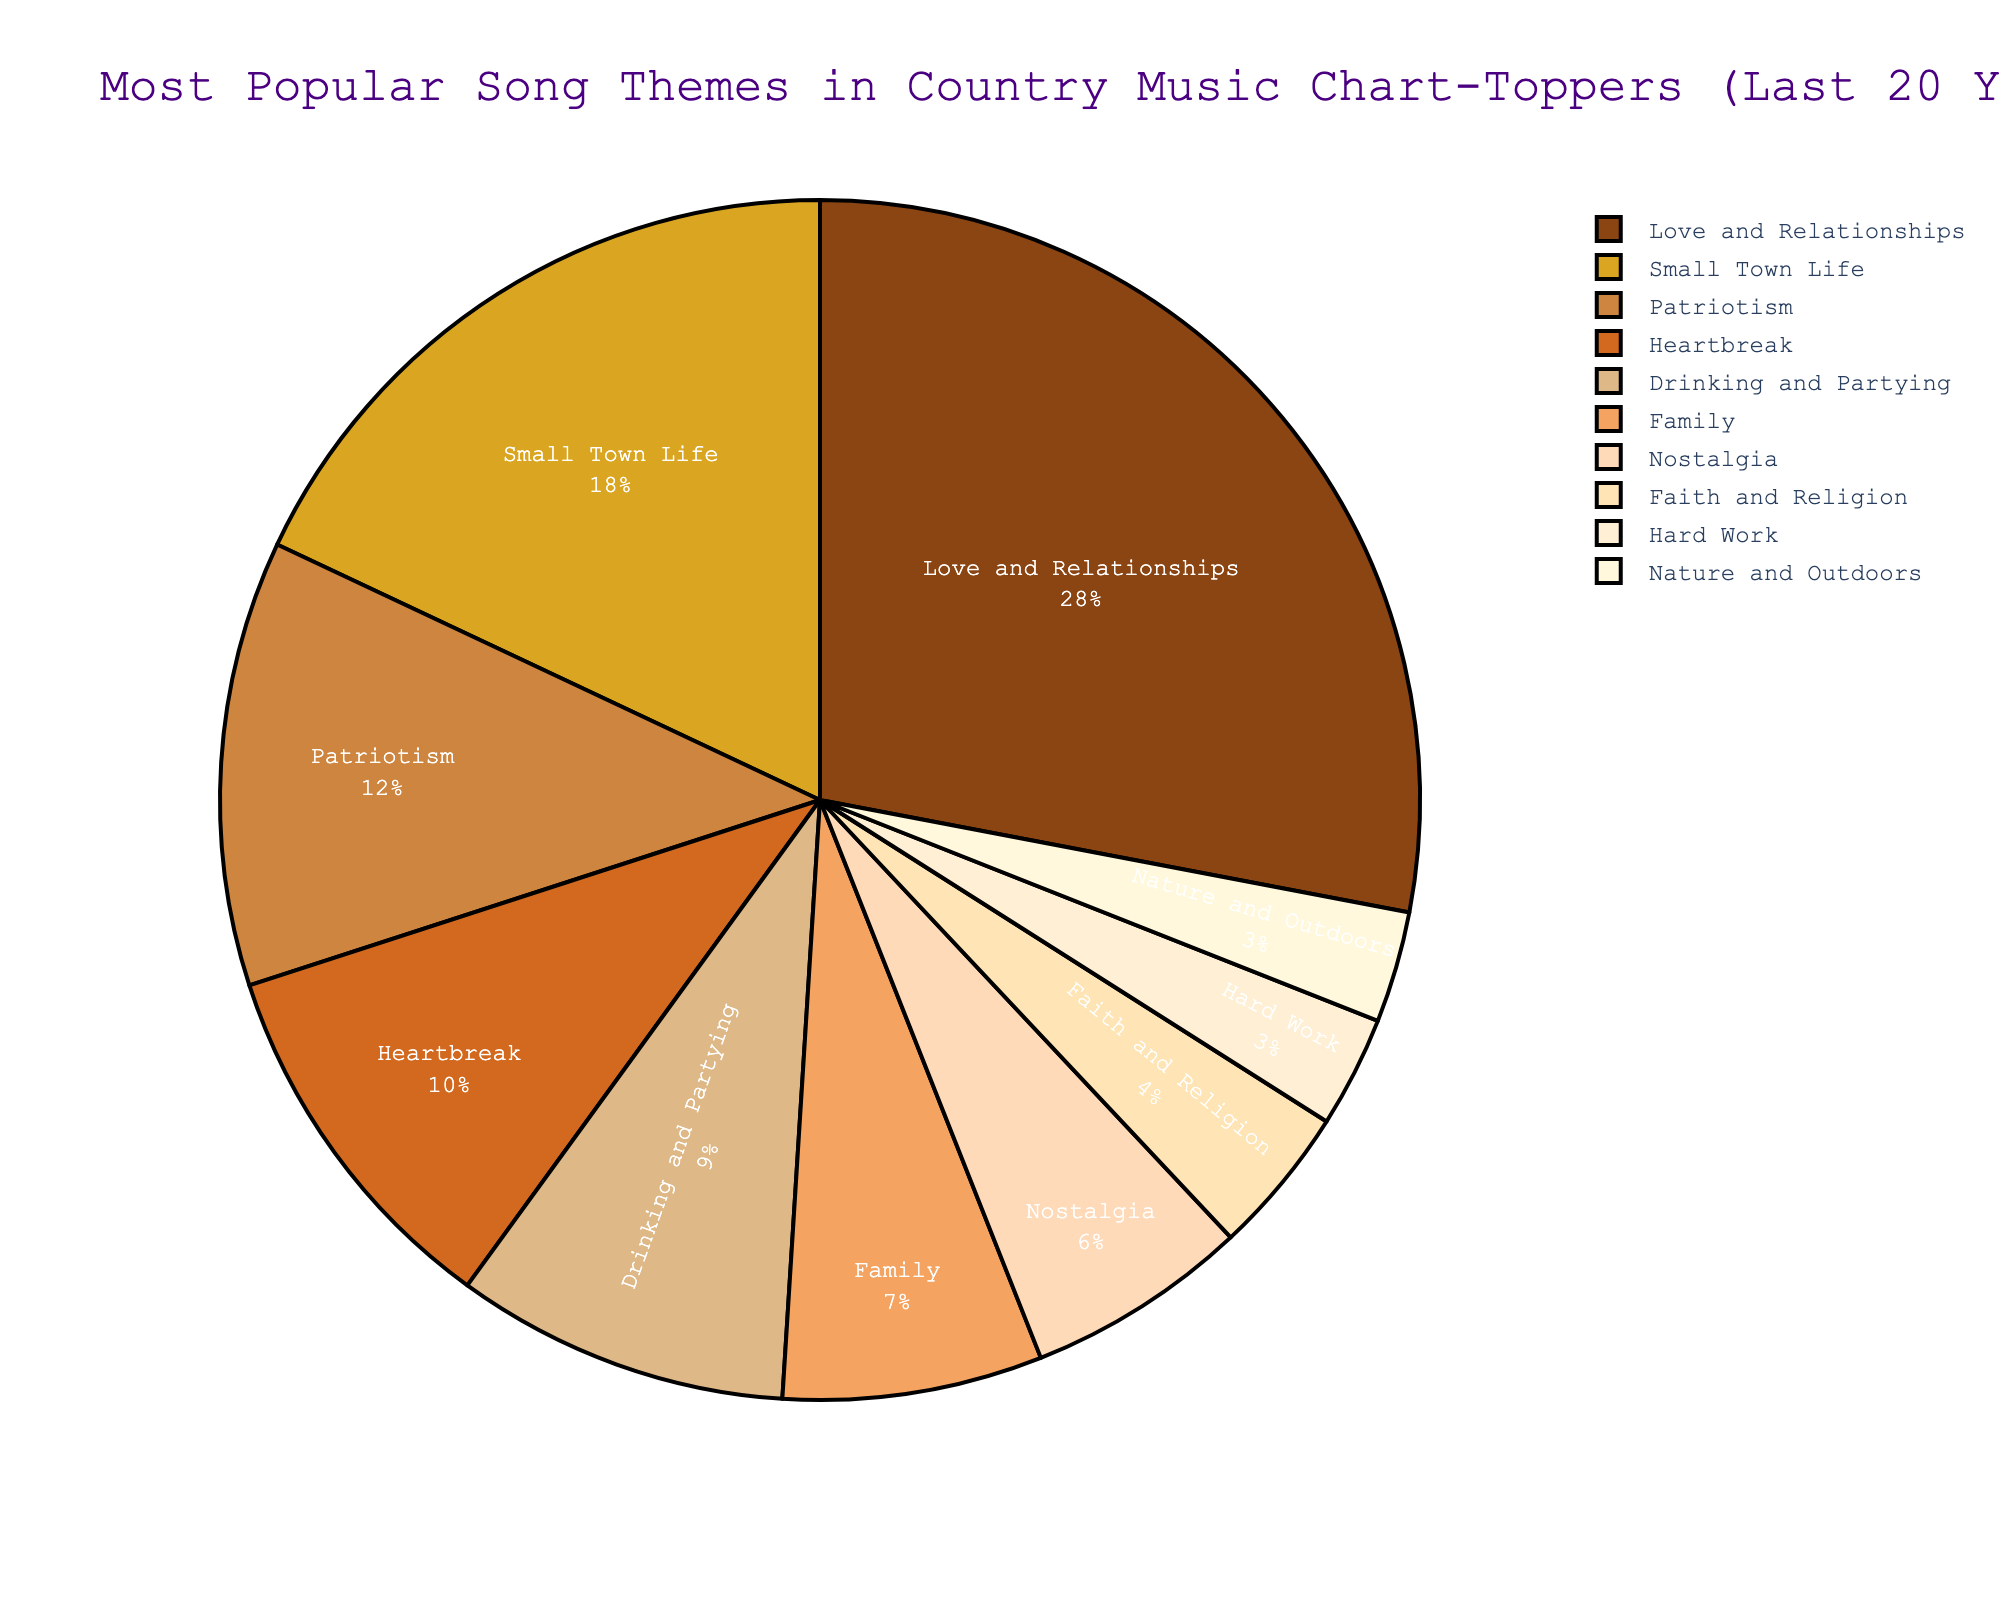What's the most popular song theme in country music chart-toppers in the last 20 years? The largest slice of the pie chart represents the most popular song theme, which is "Love and Relationships" with 28%.
Answer: Love and Relationships Which song theme is the least popular in the last 20 years? The smallest slice of the pie chart corresponds to the least popular theme, which is "Hard Work" and "Nature and Outdoors", both with 3%.
Answer: Hard Work, Nature and Outdoors What is the combined percentage of songs about "Small Town Life" and "Patriotism"? Add the percentages of "Small Town Life" (18%) and "Patriotism" (12%), resulting in 18% + 12% = 30%.
Answer: 30% How does the popularity of "Drinking and Partying" compare to "Heartbreak"? "Drinking and Partying" has 9%, while "Heartbreak" has 10%. Thus, "Heartbreak" is more popular by 1%.
Answer: Heartbreak is more popular by 1% What percentage of country songs focus on "Family" and "Faith and Religion" combined? Add the percentages of "Family" (7%) and "Faith and Religion" (4%), resulting in 7% + 4% = 11%.
Answer: 11% Are there more songs about "Nostalgia" or "Hard Work"? "Nostalgia" has a percentage of 6%, while "Hard Work" has 3%, making "Nostalgia" more popular.
Answer: Nostalgia What is the difference in popularity between "Love and Relationships" and "Drinking and Partying"? Subtract the percentage of "Drinking and Partying" (9%) from "Love and Relationships" (28%), resulting in 28% - 9% = 19%.
Answer: 19% Which themes have a percentage less than 10%? The themes with less than 10% are "Heartbreak" (10%), "Drinking and Partying" (9%), "Family" (7%), "Nostalgia" (6%), "Faith and Religion" (4%), "Hard Work" (3%), and "Nature and Outdoors" (3%).
Answer: Heartbreak, Drinking and Partying, Family, Nostalgia, Faith and Religion, Hard Work, Nature and Outdoors What is the ratio of the popularity of "Love and Relationships" to "Patriotism"? The ratio is calculated by dividing "Love and Relationships" (28%) by "Patriotism" (12%), resulting in 28/12 = 2.33.
Answer: 2.33 What song theme occupies the brownish shade in the pie chart? The brownish shade in the pie chart represents "Love and Relationships" at 28%.
Answer: Love and Relationships 